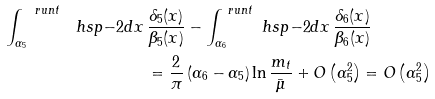<formula> <loc_0><loc_0><loc_500><loc_500>\int _ { \alpha _ { 5 } } ^ { \ r u n { t } } \ h s p { - 2 } d x \, & \frac { \delta _ { 5 } ( x ) } { \beta _ { 5 } ( x ) } - \int _ { \alpha _ { 6 } } ^ { \ r u n { t } } \ h s p { - 2 } d x \, \frac { \delta _ { 6 } ( x ) } { \beta _ { 6 } ( x ) } \, \\ & = \frac { 2 } { \pi } \left ( \alpha _ { 6 } - \alpha _ { 5 } \right ) \ln \frac { m _ { t } } { \bar { \mu } } + O \left ( \alpha _ { 5 } ^ { 2 } \right ) = O \left ( \alpha _ { 5 } ^ { 2 } \right )</formula> 